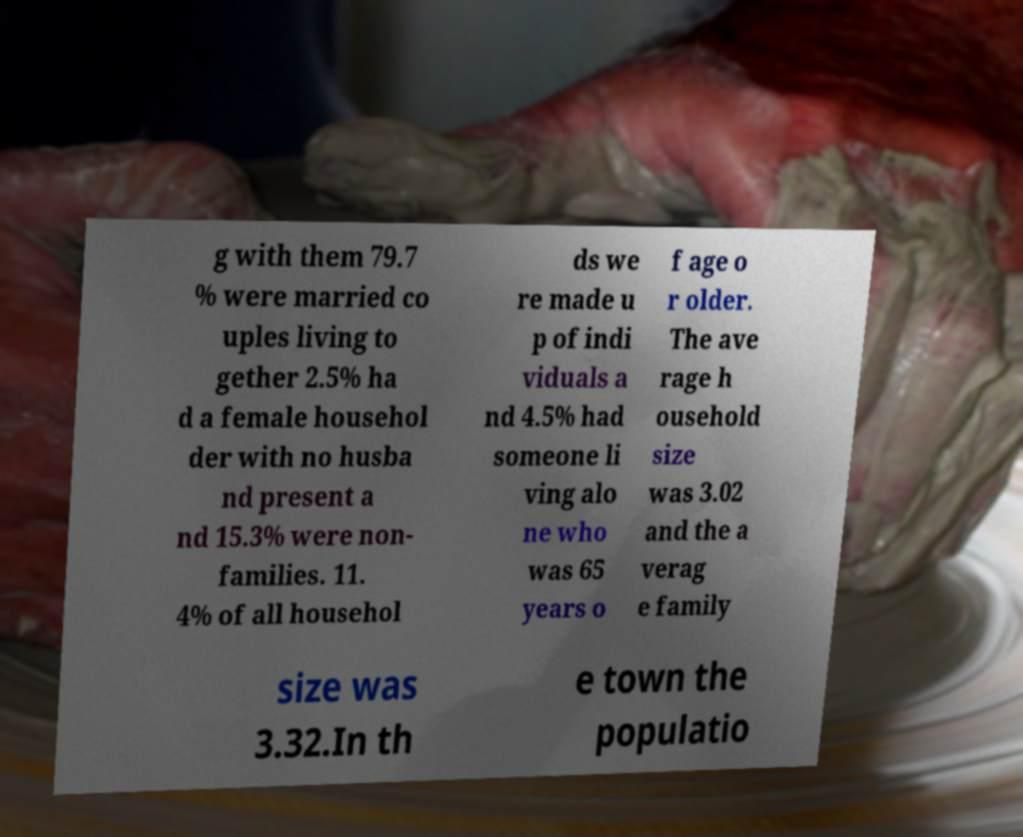Could you extract and type out the text from this image? g with them 79.7 % were married co uples living to gether 2.5% ha d a female househol der with no husba nd present a nd 15.3% were non- families. 11. 4% of all househol ds we re made u p of indi viduals a nd 4.5% had someone li ving alo ne who was 65 years o f age o r older. The ave rage h ousehold size was 3.02 and the a verag e family size was 3.32.In th e town the populatio 